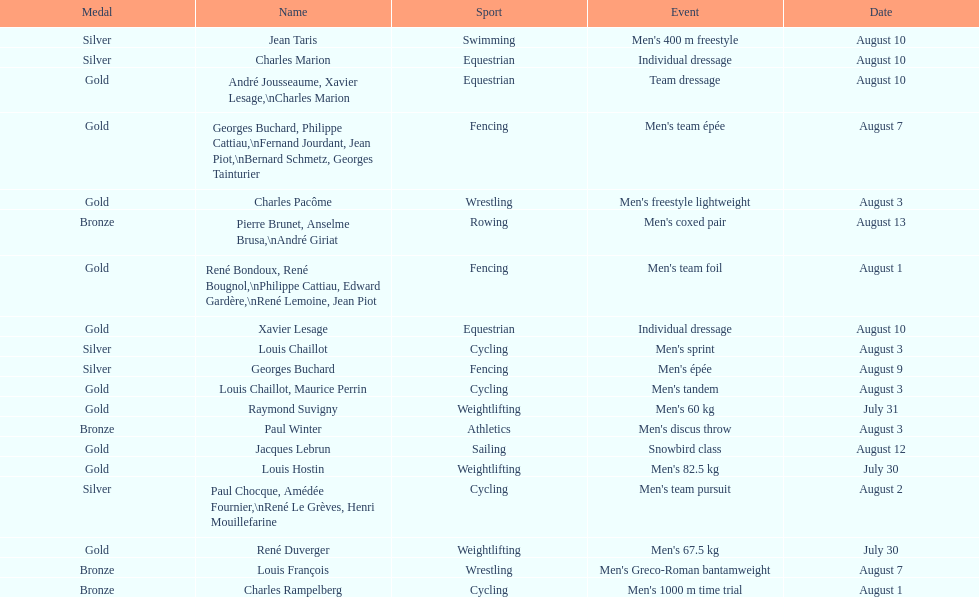Was there more gold medals won than silver? Yes. 